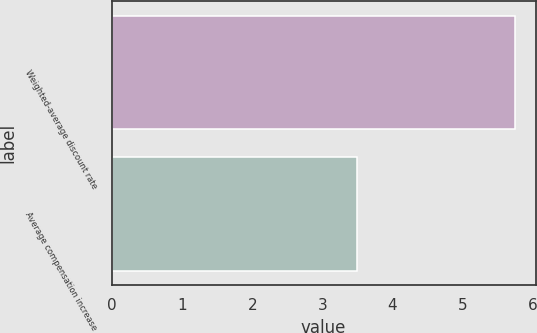Convert chart. <chart><loc_0><loc_0><loc_500><loc_500><bar_chart><fcel>Weighted-average discount rate<fcel>Average compensation increase<nl><fcel>5.75<fcel>3.5<nl></chart> 